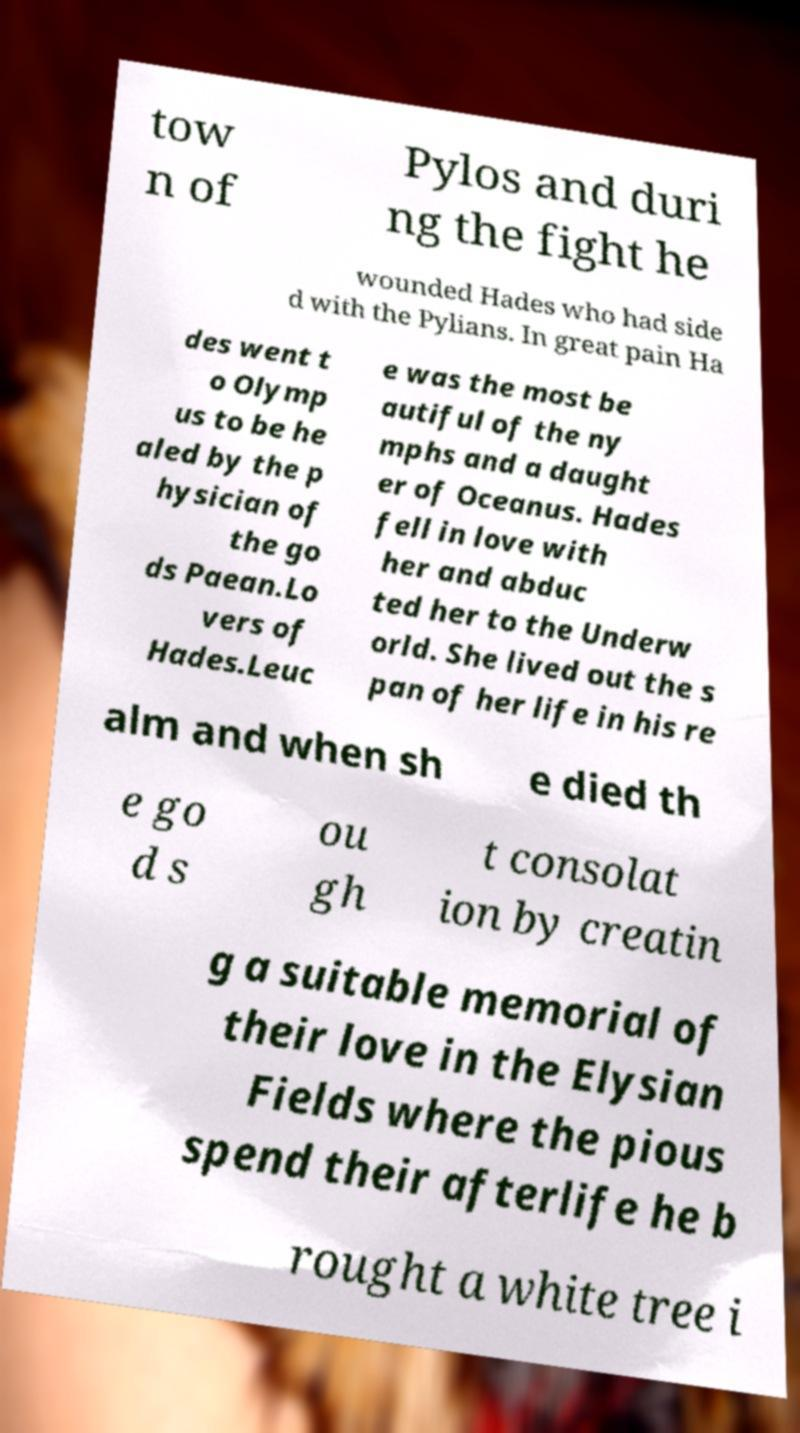Can you accurately transcribe the text from the provided image for me? tow n of Pylos and duri ng the fight he wounded Hades who had side d with the Pylians. In great pain Ha des went t o Olymp us to be he aled by the p hysician of the go ds Paean.Lo vers of Hades.Leuc e was the most be autiful of the ny mphs and a daught er of Oceanus. Hades fell in love with her and abduc ted her to the Underw orld. She lived out the s pan of her life in his re alm and when sh e died th e go d s ou gh t consolat ion by creatin g a suitable memorial of their love in the Elysian Fields where the pious spend their afterlife he b rought a white tree i 